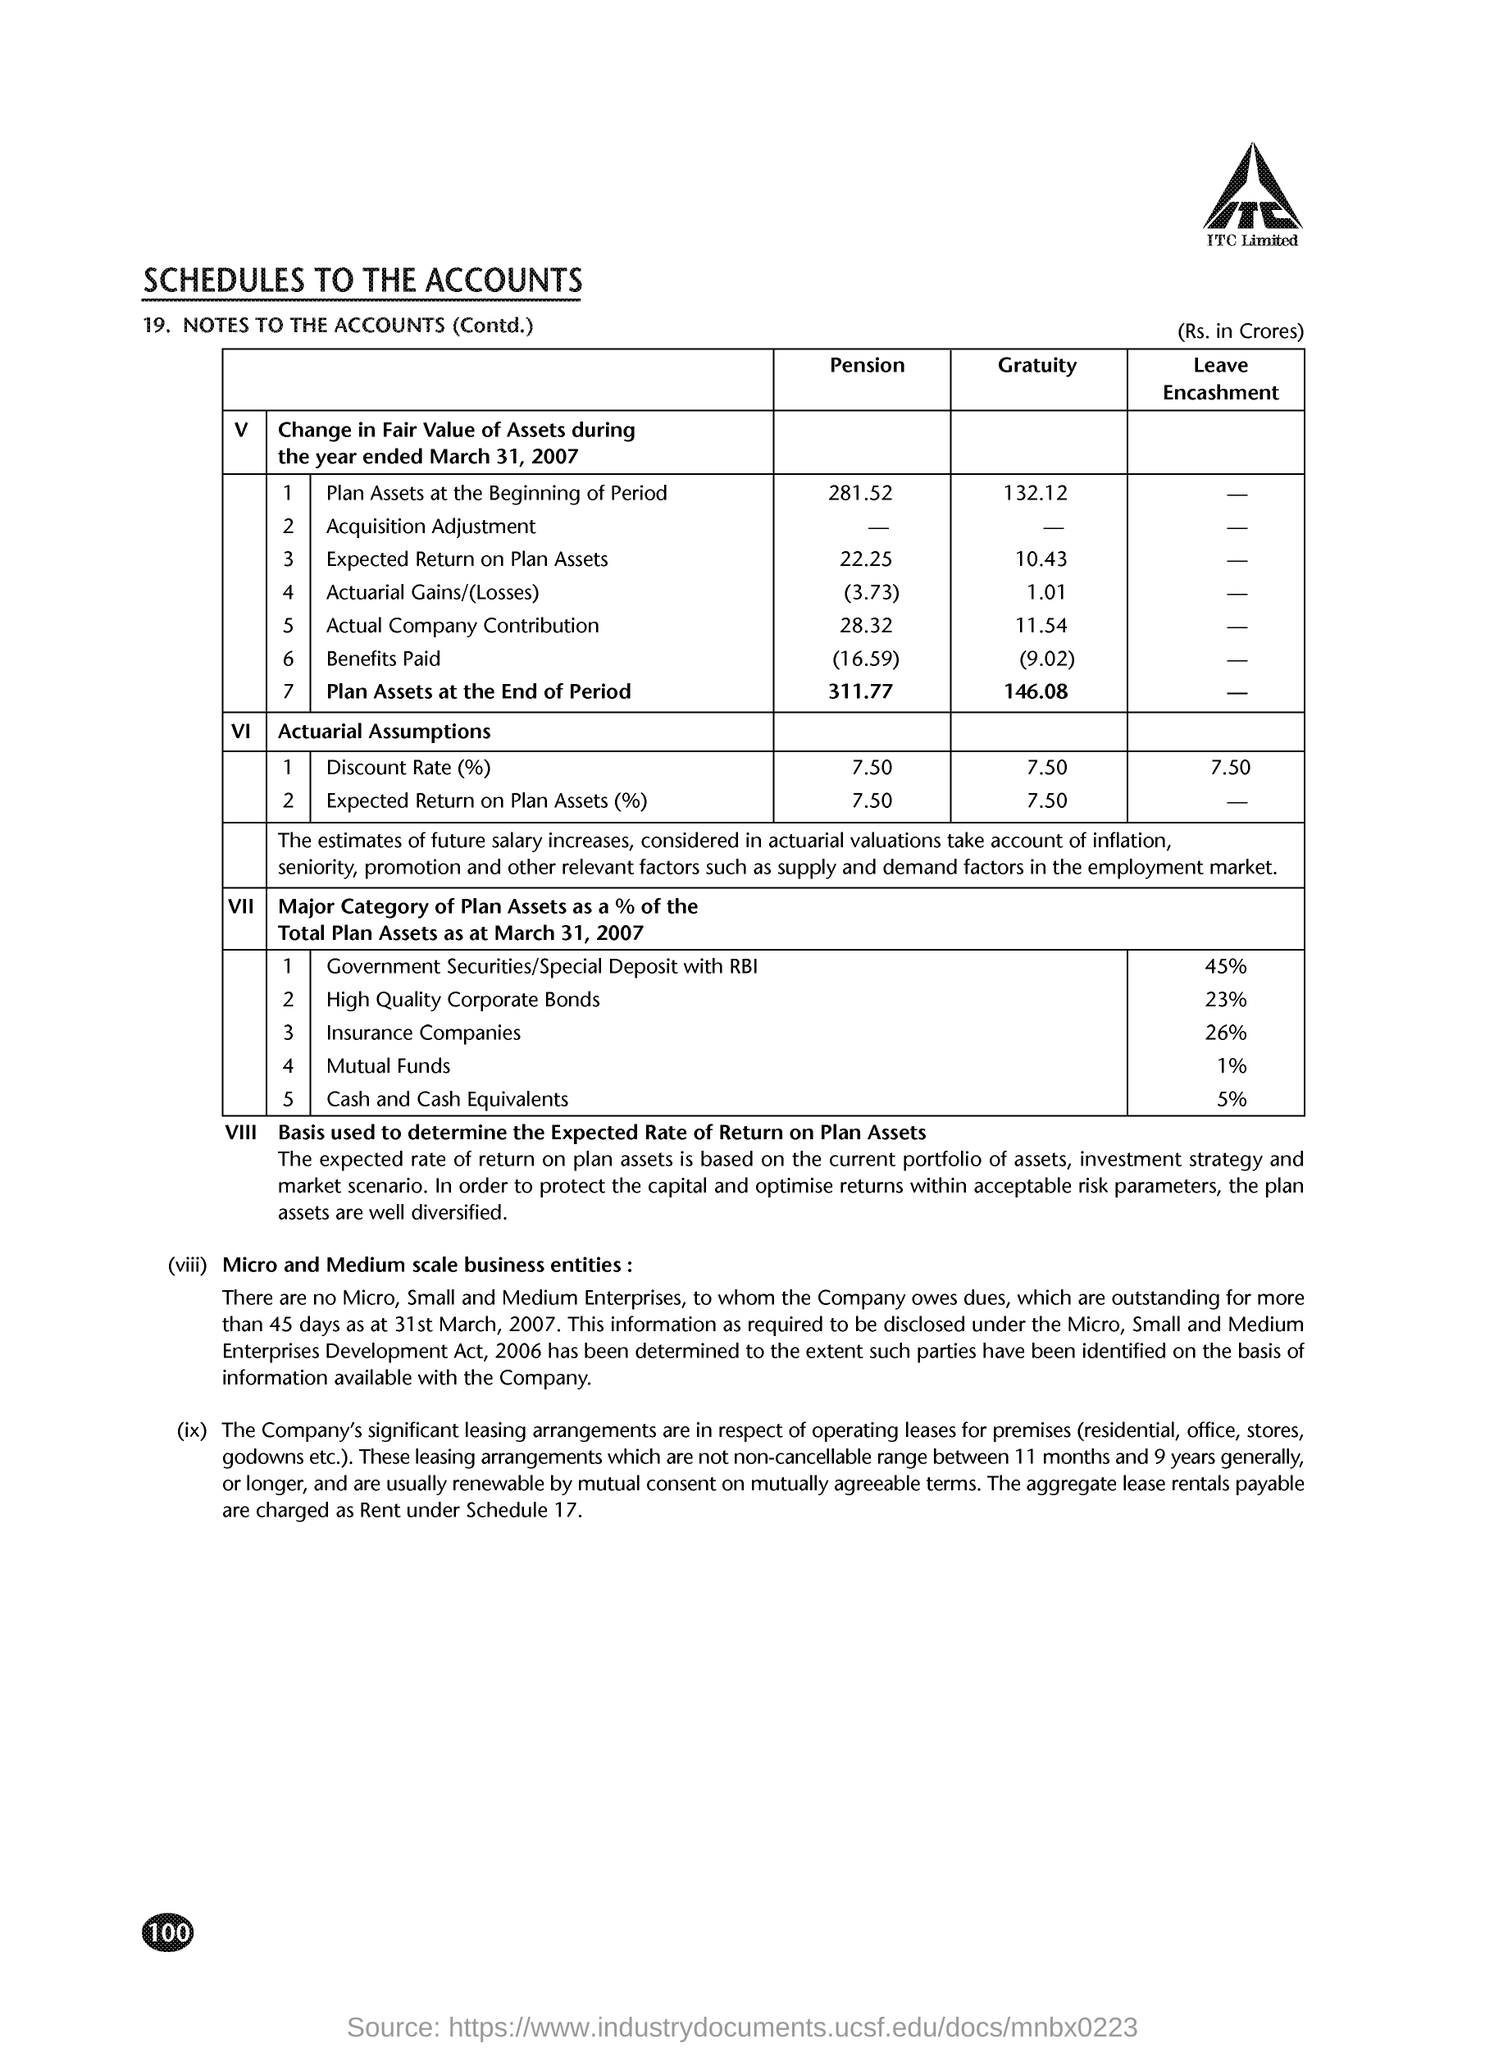What is the plan assets at the beginning of period of pension?
Provide a succinct answer. 281.52. 